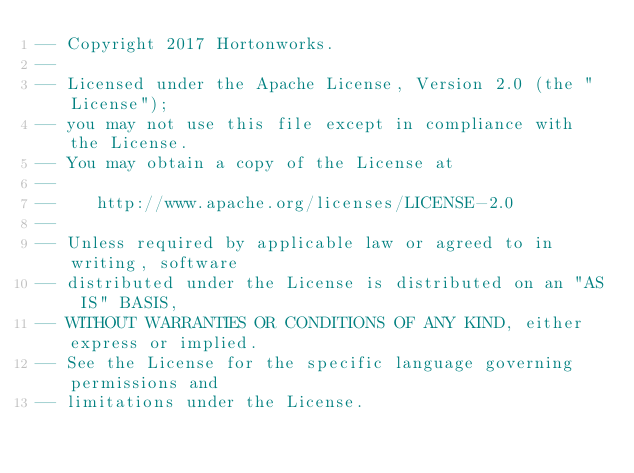<code> <loc_0><loc_0><loc_500><loc_500><_SQL_>-- Copyright 2017 Hortonworks.
--
-- Licensed under the Apache License, Version 2.0 (the "License");
-- you may not use this file except in compliance with the License.
-- You may obtain a copy of the License at
--
--    http://www.apache.org/licenses/LICENSE-2.0
--
-- Unless required by applicable law or agreed to in writing, software
-- distributed under the License is distributed on an "AS IS" BASIS,
-- WITHOUT WARRANTIES OR CONDITIONS OF ANY KIND, either express or implied.
-- See the License for the specific language governing permissions and
-- limitations under the License.
</code> 